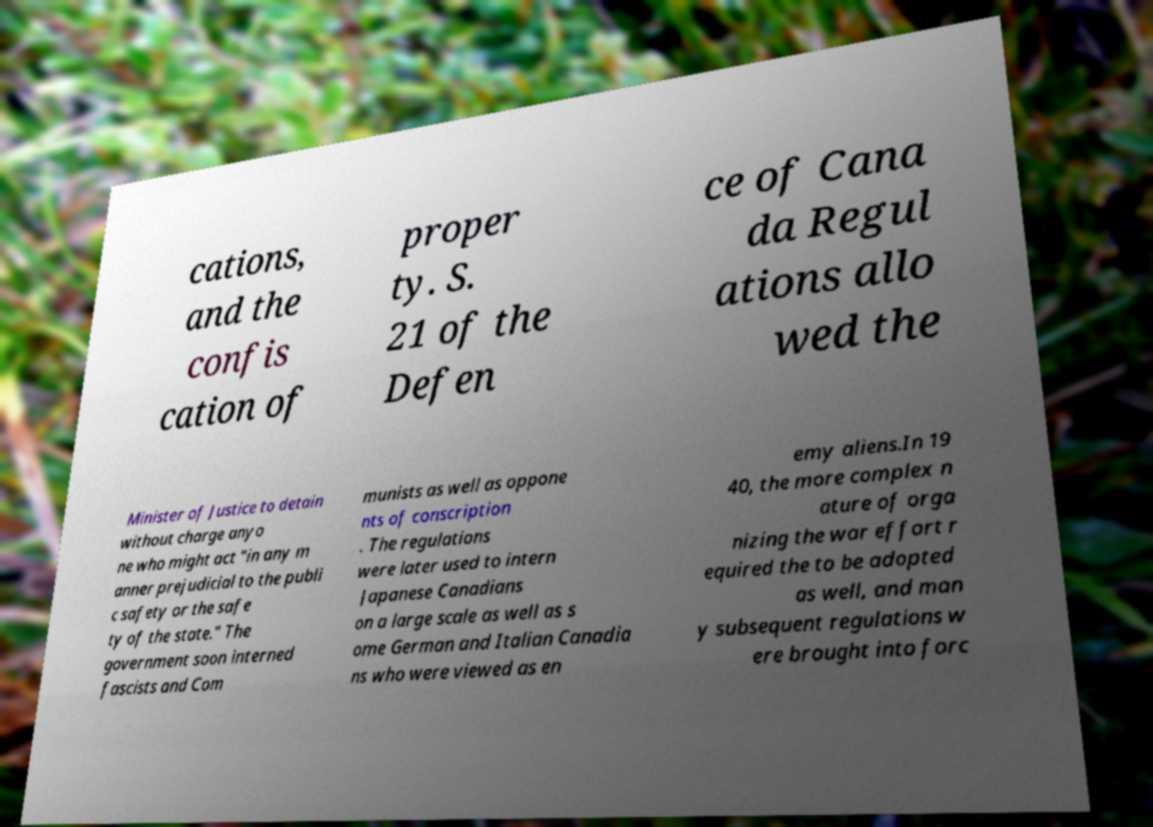What messages or text are displayed in this image? I need them in a readable, typed format. cations, and the confis cation of proper ty. S. 21 of the Defen ce of Cana da Regul ations allo wed the Minister of Justice to detain without charge anyo ne who might act "in any m anner prejudicial to the publi c safety or the safe ty of the state." The government soon interned fascists and Com munists as well as oppone nts of conscription . The regulations were later used to intern Japanese Canadians on a large scale as well as s ome German and Italian Canadia ns who were viewed as en emy aliens.In 19 40, the more complex n ature of orga nizing the war effort r equired the to be adopted as well, and man y subsequent regulations w ere brought into forc 